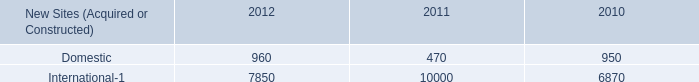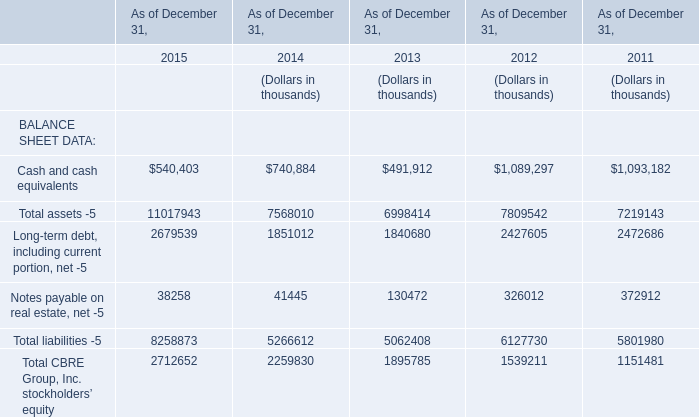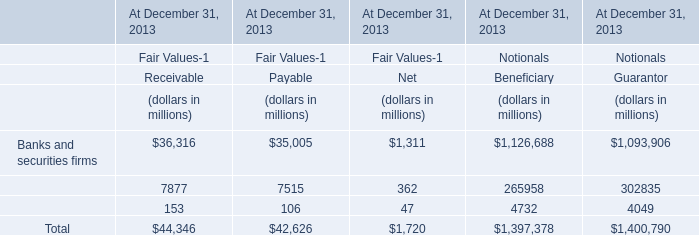in 2012 , what percent of new sites were foreign? 
Computations: (7850 / (960 + 7850))
Answer: 0.89103. 